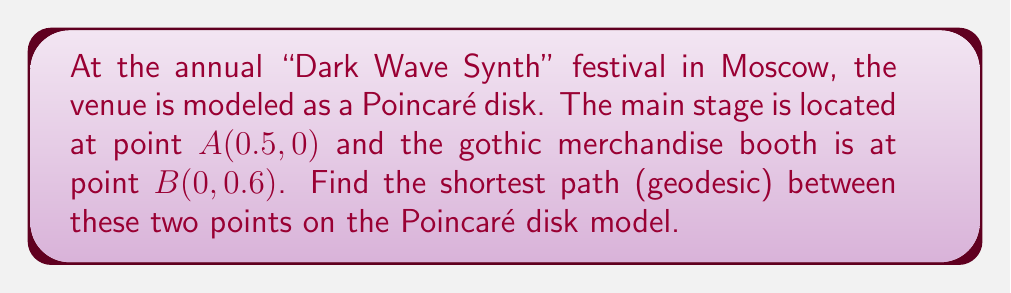Teach me how to tackle this problem. To find the shortest path between two points on a Poincaré disk model, we need to follow these steps:

1) First, we need to determine if the line connecting the two points passes through the origin. In this case, it doesn't, so we'll need to find the circle that's orthogonal to the unit circle and passes through both points.

2) The general equation for a circle orthogonal to the unit circle is:
   $$(x-a)^2 + (y-b)^2 = a^2 + b^2 - 1$$
   where $(a,b)$ is the center of the circle.

3) We know that this circle passes through points $A(0.5, 0)$ and $B(0, 0.6)$. Substituting these into the equation:
   $$(0.5-a)^2 + (0-b)^2 = a^2 + b^2 - 1$$
   $$(0-a)^2 + (0.6-b)^2 = a^2 + b^2 - 1$$

4) Expanding these equations:
   $$0.25 - a + a^2 + b^2 = a^2 + b^2 - 1$$
   $$a^2 + 0.36 - 1.2b + b^2 = a^2 + b^2 - 1$$

5) Simplifying:
   $$a = 0.625$$
   $$b = 0.3$$

6) So the center of our circle is $(0.625, 0.3)$.

7) The hyperbolic distance between the points is given by:
   $$d = 2 \tanh^{-1}\left(\frac{|z_1 - z_2|}{|1 - \bar{z_1}z_2|}\right)$$
   where $z_1$ and $z_2$ are the complex representations of the points.

8) $z_1 = 0.5 + 0i = 0.5$, $z_2 = 0 + 0.6i = 0.6i$

9) Plugging into the formula:
   $$d = 2 \tanh^{-1}\left(\frac{|0.5 - 0.6i|}{|1 - 0.5(0.6i)|}\right)$$

10) Simplifying:
    $$d = 2 \tanh^{-1}\left(\frac{\sqrt{0.25 + 0.36}}{\sqrt{1 + 0.09}}\right) = 2 \tanh^{-1}\left(\frac{\sqrt{0.61}}{\sqrt{1.09}}\right)$$

11) Calculating:
    $$d \approx 1.0986$$

[asy]
import geometry;

unitcircle();
dot((0.5,0),red);
dot((0,0.6),red);
draw((0.5,0)--(0,0.6),blue);
draw(arc((0.625,0.3),0.78,210,330),red);
label("A",(0.5,0),SE);
label("B",(0,0.6),NW);
[/asy]
Answer: $2 \tanh^{-1}\left(\frac{\sqrt{0.61}}{\sqrt{1.09}}\right) \approx 1.0986$ 